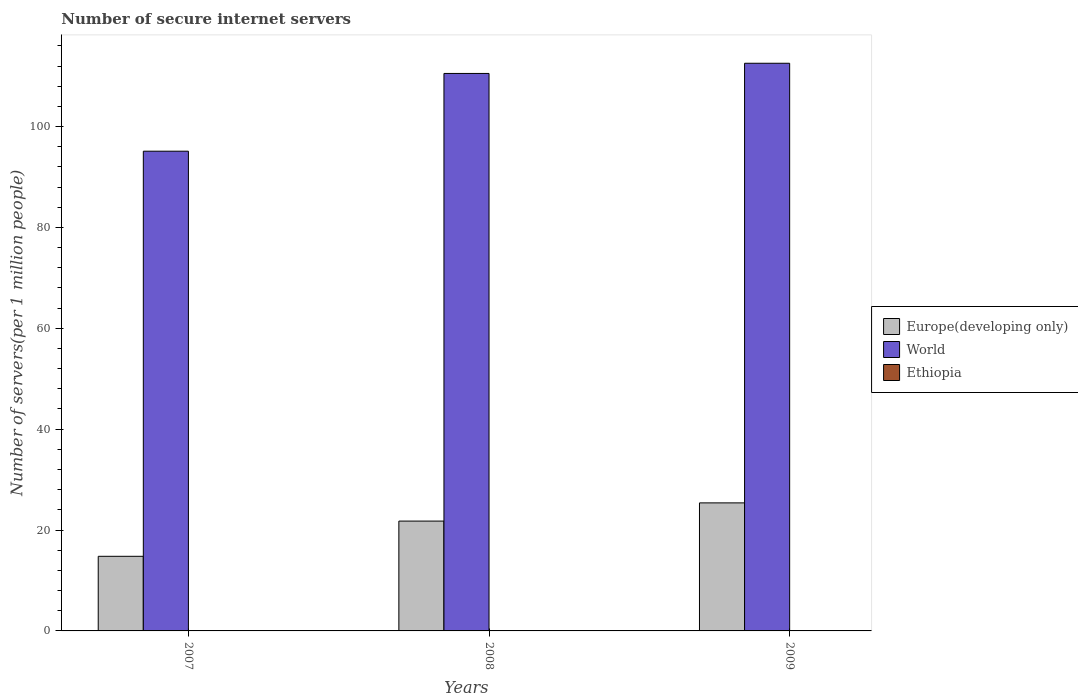How many different coloured bars are there?
Make the answer very short. 3. How many groups of bars are there?
Your answer should be compact. 3. How many bars are there on the 1st tick from the left?
Give a very brief answer. 3. What is the label of the 2nd group of bars from the left?
Offer a terse response. 2008. What is the number of secure internet servers in Ethiopia in 2008?
Provide a succinct answer. 0.04. Across all years, what is the maximum number of secure internet servers in Ethiopia?
Make the answer very short. 0.06. Across all years, what is the minimum number of secure internet servers in Ethiopia?
Make the answer very short. 0.01. In which year was the number of secure internet servers in Ethiopia maximum?
Your answer should be very brief. 2009. What is the total number of secure internet servers in World in the graph?
Offer a very short reply. 318.19. What is the difference between the number of secure internet servers in World in 2007 and that in 2008?
Provide a short and direct response. -15.41. What is the difference between the number of secure internet servers in Europe(developing only) in 2007 and the number of secure internet servers in World in 2009?
Your response must be concise. -97.75. What is the average number of secure internet servers in World per year?
Your response must be concise. 106.06. In the year 2008, what is the difference between the number of secure internet servers in World and number of secure internet servers in Ethiopia?
Ensure brevity in your answer.  110.49. What is the ratio of the number of secure internet servers in Europe(developing only) in 2007 to that in 2009?
Offer a terse response. 0.58. What is the difference between the highest and the second highest number of secure internet servers in Europe(developing only)?
Make the answer very short. 3.61. What is the difference between the highest and the lowest number of secure internet servers in Ethiopia?
Make the answer very short. 0.05. What does the 3rd bar from the right in 2008 represents?
Offer a very short reply. Europe(developing only). How many years are there in the graph?
Keep it short and to the point. 3. What is the difference between two consecutive major ticks on the Y-axis?
Keep it short and to the point. 20. Are the values on the major ticks of Y-axis written in scientific E-notation?
Offer a very short reply. No. Does the graph contain any zero values?
Provide a short and direct response. No. What is the title of the graph?
Give a very brief answer. Number of secure internet servers. What is the label or title of the X-axis?
Provide a succinct answer. Years. What is the label or title of the Y-axis?
Provide a succinct answer. Number of servers(per 1 million people). What is the Number of servers(per 1 million people) in Europe(developing only) in 2007?
Provide a succinct answer. 14.79. What is the Number of servers(per 1 million people) of World in 2007?
Provide a short and direct response. 95.11. What is the Number of servers(per 1 million people) of Ethiopia in 2007?
Your response must be concise. 0.01. What is the Number of servers(per 1 million people) in Europe(developing only) in 2008?
Your answer should be very brief. 21.78. What is the Number of servers(per 1 million people) of World in 2008?
Your response must be concise. 110.53. What is the Number of servers(per 1 million people) of Ethiopia in 2008?
Keep it short and to the point. 0.04. What is the Number of servers(per 1 million people) of Europe(developing only) in 2009?
Keep it short and to the point. 25.39. What is the Number of servers(per 1 million people) in World in 2009?
Make the answer very short. 112.55. What is the Number of servers(per 1 million people) of Ethiopia in 2009?
Your response must be concise. 0.06. Across all years, what is the maximum Number of servers(per 1 million people) of Europe(developing only)?
Keep it short and to the point. 25.39. Across all years, what is the maximum Number of servers(per 1 million people) of World?
Make the answer very short. 112.55. Across all years, what is the maximum Number of servers(per 1 million people) of Ethiopia?
Provide a succinct answer. 0.06. Across all years, what is the minimum Number of servers(per 1 million people) of Europe(developing only)?
Your answer should be compact. 14.79. Across all years, what is the minimum Number of servers(per 1 million people) of World?
Keep it short and to the point. 95.11. Across all years, what is the minimum Number of servers(per 1 million people) of Ethiopia?
Ensure brevity in your answer.  0.01. What is the total Number of servers(per 1 million people) of Europe(developing only) in the graph?
Your response must be concise. 61.95. What is the total Number of servers(per 1 million people) of World in the graph?
Provide a succinct answer. 318.19. What is the total Number of servers(per 1 million people) in Ethiopia in the graph?
Make the answer very short. 0.11. What is the difference between the Number of servers(per 1 million people) of Europe(developing only) in 2007 and that in 2008?
Your answer should be very brief. -6.98. What is the difference between the Number of servers(per 1 million people) in World in 2007 and that in 2008?
Provide a succinct answer. -15.41. What is the difference between the Number of servers(per 1 million people) in Ethiopia in 2007 and that in 2008?
Your answer should be very brief. -0.02. What is the difference between the Number of servers(per 1 million people) in Europe(developing only) in 2007 and that in 2009?
Your answer should be compact. -10.59. What is the difference between the Number of servers(per 1 million people) in World in 2007 and that in 2009?
Your response must be concise. -17.43. What is the difference between the Number of servers(per 1 million people) of Ethiopia in 2007 and that in 2009?
Your answer should be very brief. -0.05. What is the difference between the Number of servers(per 1 million people) of Europe(developing only) in 2008 and that in 2009?
Offer a very short reply. -3.61. What is the difference between the Number of servers(per 1 million people) of World in 2008 and that in 2009?
Ensure brevity in your answer.  -2.02. What is the difference between the Number of servers(per 1 million people) in Ethiopia in 2008 and that in 2009?
Give a very brief answer. -0.02. What is the difference between the Number of servers(per 1 million people) of Europe(developing only) in 2007 and the Number of servers(per 1 million people) of World in 2008?
Give a very brief answer. -95.73. What is the difference between the Number of servers(per 1 million people) of Europe(developing only) in 2007 and the Number of servers(per 1 million people) of Ethiopia in 2008?
Offer a very short reply. 14.76. What is the difference between the Number of servers(per 1 million people) of World in 2007 and the Number of servers(per 1 million people) of Ethiopia in 2008?
Provide a succinct answer. 95.08. What is the difference between the Number of servers(per 1 million people) of Europe(developing only) in 2007 and the Number of servers(per 1 million people) of World in 2009?
Provide a succinct answer. -97.75. What is the difference between the Number of servers(per 1 million people) of Europe(developing only) in 2007 and the Number of servers(per 1 million people) of Ethiopia in 2009?
Your answer should be compact. 14.73. What is the difference between the Number of servers(per 1 million people) in World in 2007 and the Number of servers(per 1 million people) in Ethiopia in 2009?
Your answer should be compact. 95.06. What is the difference between the Number of servers(per 1 million people) in Europe(developing only) in 2008 and the Number of servers(per 1 million people) in World in 2009?
Give a very brief answer. -90.77. What is the difference between the Number of servers(per 1 million people) in Europe(developing only) in 2008 and the Number of servers(per 1 million people) in Ethiopia in 2009?
Give a very brief answer. 21.72. What is the difference between the Number of servers(per 1 million people) of World in 2008 and the Number of servers(per 1 million people) of Ethiopia in 2009?
Your answer should be compact. 110.47. What is the average Number of servers(per 1 million people) of Europe(developing only) per year?
Your answer should be very brief. 20.65. What is the average Number of servers(per 1 million people) in World per year?
Provide a short and direct response. 106.06. What is the average Number of servers(per 1 million people) of Ethiopia per year?
Provide a succinct answer. 0.04. In the year 2007, what is the difference between the Number of servers(per 1 million people) of Europe(developing only) and Number of servers(per 1 million people) of World?
Provide a short and direct response. -80.32. In the year 2007, what is the difference between the Number of servers(per 1 million people) of Europe(developing only) and Number of servers(per 1 million people) of Ethiopia?
Provide a succinct answer. 14.78. In the year 2007, what is the difference between the Number of servers(per 1 million people) of World and Number of servers(per 1 million people) of Ethiopia?
Provide a succinct answer. 95.1. In the year 2008, what is the difference between the Number of servers(per 1 million people) of Europe(developing only) and Number of servers(per 1 million people) of World?
Give a very brief answer. -88.75. In the year 2008, what is the difference between the Number of servers(per 1 million people) in Europe(developing only) and Number of servers(per 1 million people) in Ethiopia?
Offer a terse response. 21.74. In the year 2008, what is the difference between the Number of servers(per 1 million people) of World and Number of servers(per 1 million people) of Ethiopia?
Provide a succinct answer. 110.49. In the year 2009, what is the difference between the Number of servers(per 1 million people) of Europe(developing only) and Number of servers(per 1 million people) of World?
Your response must be concise. -87.16. In the year 2009, what is the difference between the Number of servers(per 1 million people) in Europe(developing only) and Number of servers(per 1 million people) in Ethiopia?
Your answer should be compact. 25.33. In the year 2009, what is the difference between the Number of servers(per 1 million people) of World and Number of servers(per 1 million people) of Ethiopia?
Give a very brief answer. 112.49. What is the ratio of the Number of servers(per 1 million people) in Europe(developing only) in 2007 to that in 2008?
Make the answer very short. 0.68. What is the ratio of the Number of servers(per 1 million people) in World in 2007 to that in 2008?
Your response must be concise. 0.86. What is the ratio of the Number of servers(per 1 million people) in Ethiopia in 2007 to that in 2008?
Keep it short and to the point. 0.34. What is the ratio of the Number of servers(per 1 million people) of Europe(developing only) in 2007 to that in 2009?
Keep it short and to the point. 0.58. What is the ratio of the Number of servers(per 1 million people) of World in 2007 to that in 2009?
Your answer should be compact. 0.85. What is the ratio of the Number of servers(per 1 million people) in Ethiopia in 2007 to that in 2009?
Make the answer very short. 0.21. What is the ratio of the Number of servers(per 1 million people) in Europe(developing only) in 2008 to that in 2009?
Your response must be concise. 0.86. What is the ratio of the Number of servers(per 1 million people) in Ethiopia in 2008 to that in 2009?
Provide a short and direct response. 0.62. What is the difference between the highest and the second highest Number of servers(per 1 million people) in Europe(developing only)?
Give a very brief answer. 3.61. What is the difference between the highest and the second highest Number of servers(per 1 million people) in World?
Keep it short and to the point. 2.02. What is the difference between the highest and the second highest Number of servers(per 1 million people) of Ethiopia?
Your answer should be very brief. 0.02. What is the difference between the highest and the lowest Number of servers(per 1 million people) of Europe(developing only)?
Your response must be concise. 10.59. What is the difference between the highest and the lowest Number of servers(per 1 million people) of World?
Make the answer very short. 17.43. What is the difference between the highest and the lowest Number of servers(per 1 million people) of Ethiopia?
Make the answer very short. 0.05. 